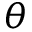Convert formula to latex. <formula><loc_0><loc_0><loc_500><loc_500>\theta</formula> 